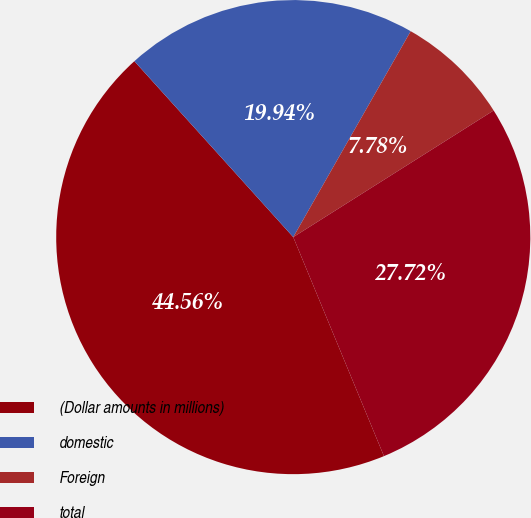Convert chart. <chart><loc_0><loc_0><loc_500><loc_500><pie_chart><fcel>(Dollar amounts in millions)<fcel>domestic<fcel>Foreign<fcel>total<nl><fcel>44.56%<fcel>19.94%<fcel>7.78%<fcel>27.72%<nl></chart> 